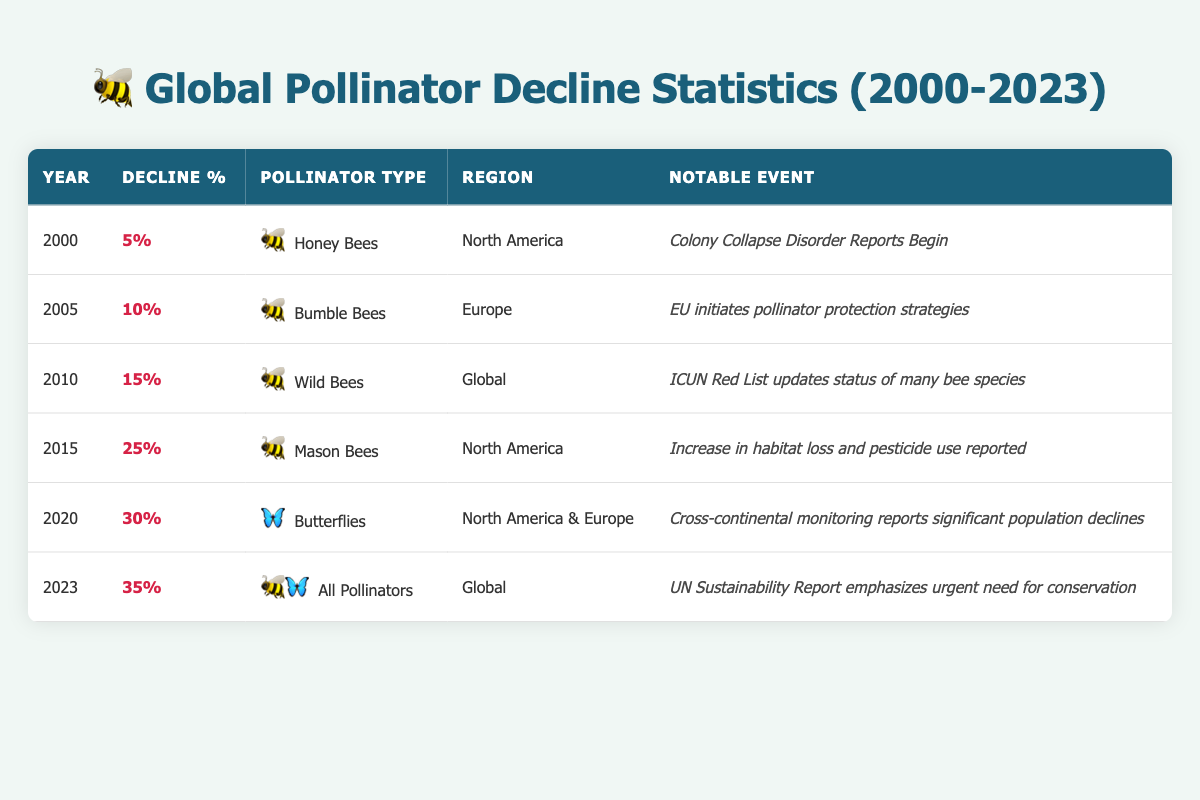What was the decline percentage of Honey Bees in North America in 2000? The table shows that the decline percentage for Honey Bees in North America in the year 2000 was 5%.
Answer: 5% Which pollinator type saw a 10% decline in 2005? The table indicates that Bumble Bees experienced a 10% decline in 2005.
Answer: Bumble Bees Is the notable event for 2015 related to habitat loss? In the table, the notable event for 2015 mentions "Increase in habitat loss and pesticide use reported," which confirms that it is indeed related to habitat loss.
Answer: Yes What is the average decline percentage for pollinator types from 2000 to 2023? To find the average, sum the decline percentages: 5 + 10 + 15 + 25 + 30 + 35 = 120. There are 6 years, so the average is 120/6 = 20.
Answer: 20 Which regions reported a decline of 30% or more, and how many such instances are there? The table shows two instances of decline percentages of 30% or more: in 2020 (30% decline for Butterflies in North America & Europe) and 2023 (35% decline for All Pollinators globally). So, there are two instances.
Answer: 2 What notable event occurred for Wild Bees in 2010? According to the table, the notable event for Wild Bees in 2010 was the "ICUN Red List updates status of many bee species."
Answer: ICUN Red List updates status of many bee species How much did the decline percentage increase from 2000 to 2023? The decline percentage in 2000 was 5%, and in 2023 it was 35%. The increase is 35 - 5 = 30 percentage points.
Answer: 30 percentage points Did any pollinator type decline by 25% or more before the year 2020? The table shows that Mason Bees had a 25% decline in 2015, which is before 2020. Thus, the answer is yes.
Answer: Yes 